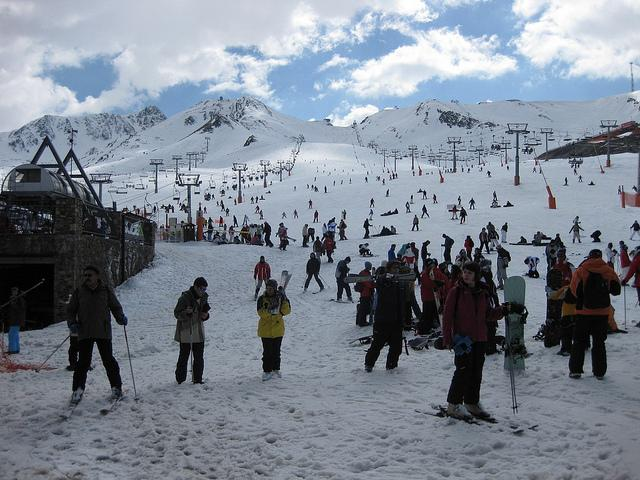How could someone near here gain elevation without expending a lot of energy? ski lift 